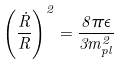Convert formula to latex. <formula><loc_0><loc_0><loc_500><loc_500>\left ( \frac { \dot { R } } { R } \right ) ^ { 2 } = \frac { 8 \pi \epsilon } { 3 m _ { p l } ^ { 2 } }</formula> 